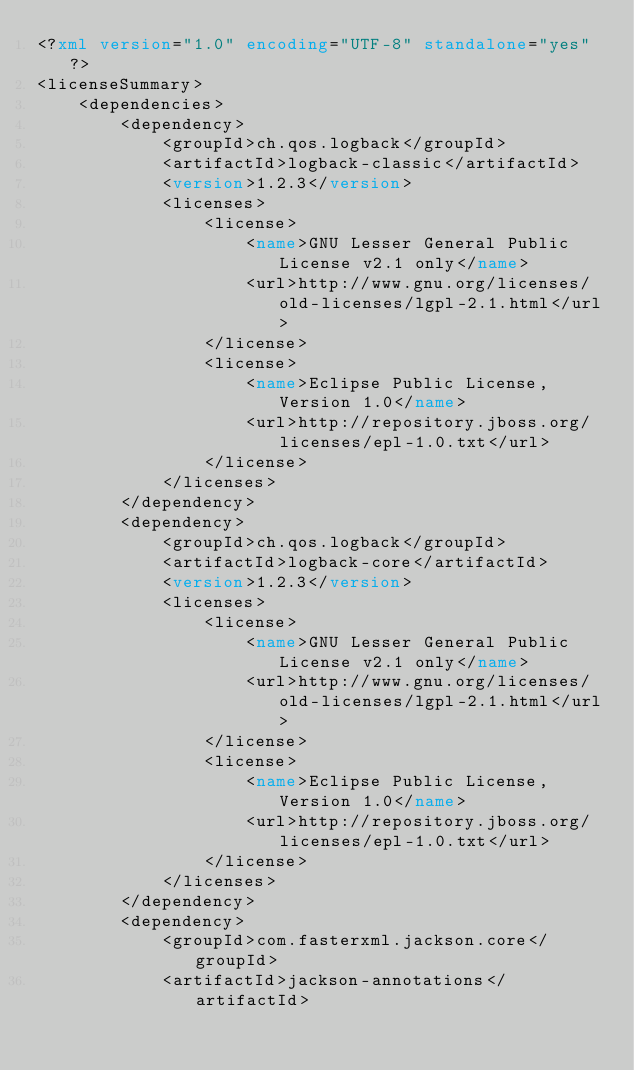Convert code to text. <code><loc_0><loc_0><loc_500><loc_500><_XML_><?xml version="1.0" encoding="UTF-8" standalone="yes"?>
<licenseSummary>
    <dependencies>
        <dependency>
            <groupId>ch.qos.logback</groupId>
            <artifactId>logback-classic</artifactId>
            <version>1.2.3</version>
            <licenses>
                <license>
                    <name>GNU Lesser General Public License v2.1 only</name>
                    <url>http://www.gnu.org/licenses/old-licenses/lgpl-2.1.html</url>
                </license>
                <license>
                    <name>Eclipse Public License, Version 1.0</name>
                    <url>http://repository.jboss.org/licenses/epl-1.0.txt</url>
                </license>
            </licenses>
        </dependency>
        <dependency>
            <groupId>ch.qos.logback</groupId>
            <artifactId>logback-core</artifactId>
            <version>1.2.3</version>
            <licenses>
                <license>
                    <name>GNU Lesser General Public License v2.1 only</name>
                    <url>http://www.gnu.org/licenses/old-licenses/lgpl-2.1.html</url>
                </license>
                <license>
                    <name>Eclipse Public License, Version 1.0</name>
                    <url>http://repository.jboss.org/licenses/epl-1.0.txt</url>
                </license>
            </licenses>
        </dependency>
        <dependency>
            <groupId>com.fasterxml.jackson.core</groupId>
            <artifactId>jackson-annotations</artifactId></code> 